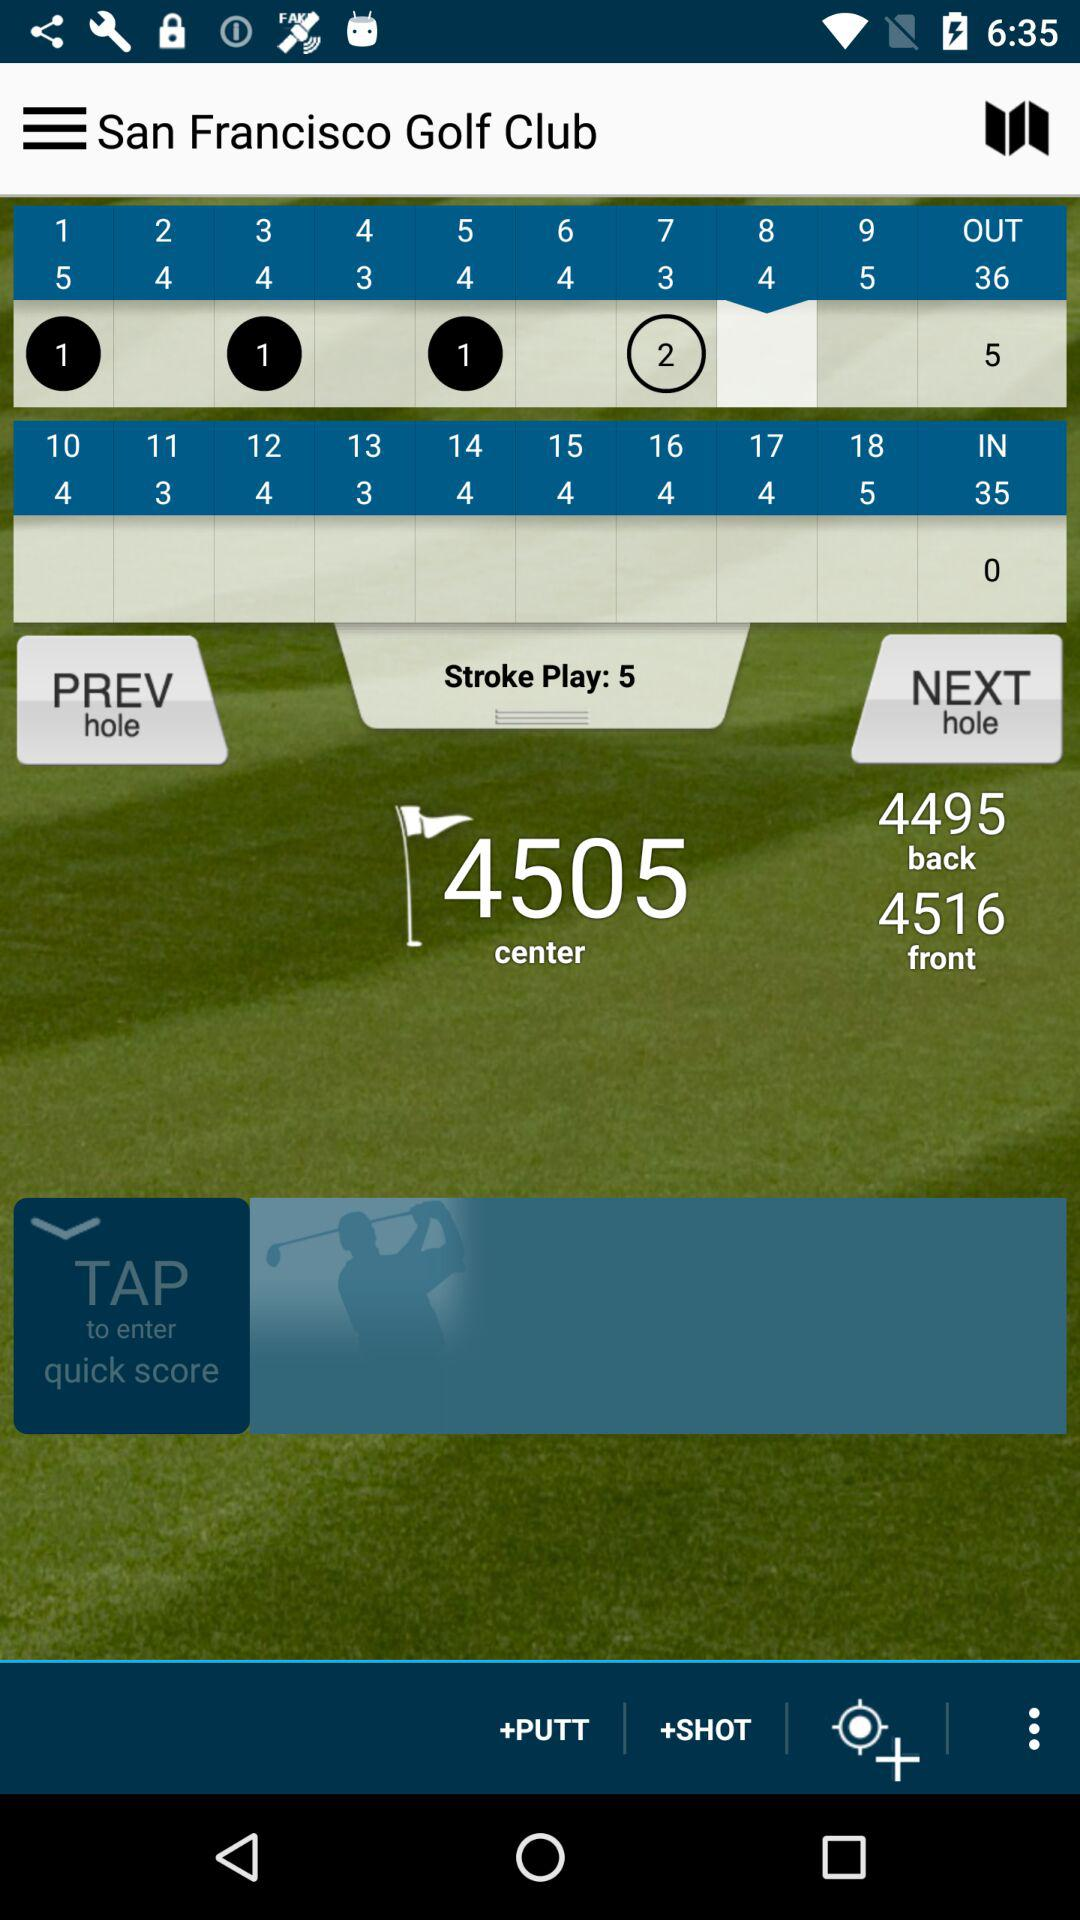What is the number of strokes played? The number of strokes played is 5. 